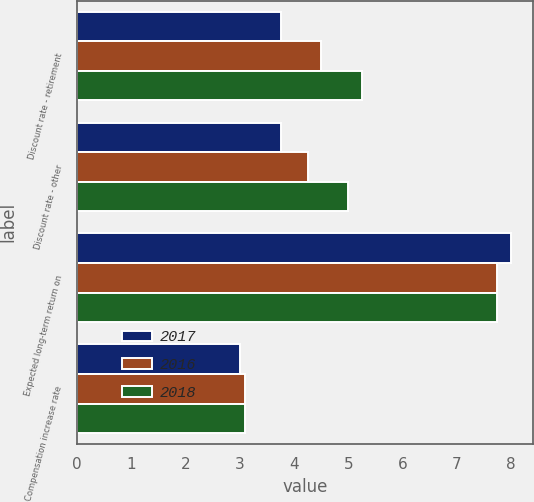Convert chart. <chart><loc_0><loc_0><loc_500><loc_500><stacked_bar_chart><ecel><fcel>Discount rate - retirement<fcel>Discount rate - other<fcel>Expected long-term return on<fcel>Compensation increase rate<nl><fcel>2017<fcel>3.75<fcel>3.75<fcel>8<fcel>3<nl><fcel>2016<fcel>4.5<fcel>4.25<fcel>7.75<fcel>3.1<nl><fcel>2018<fcel>5.25<fcel>5<fcel>7.75<fcel>3.1<nl></chart> 